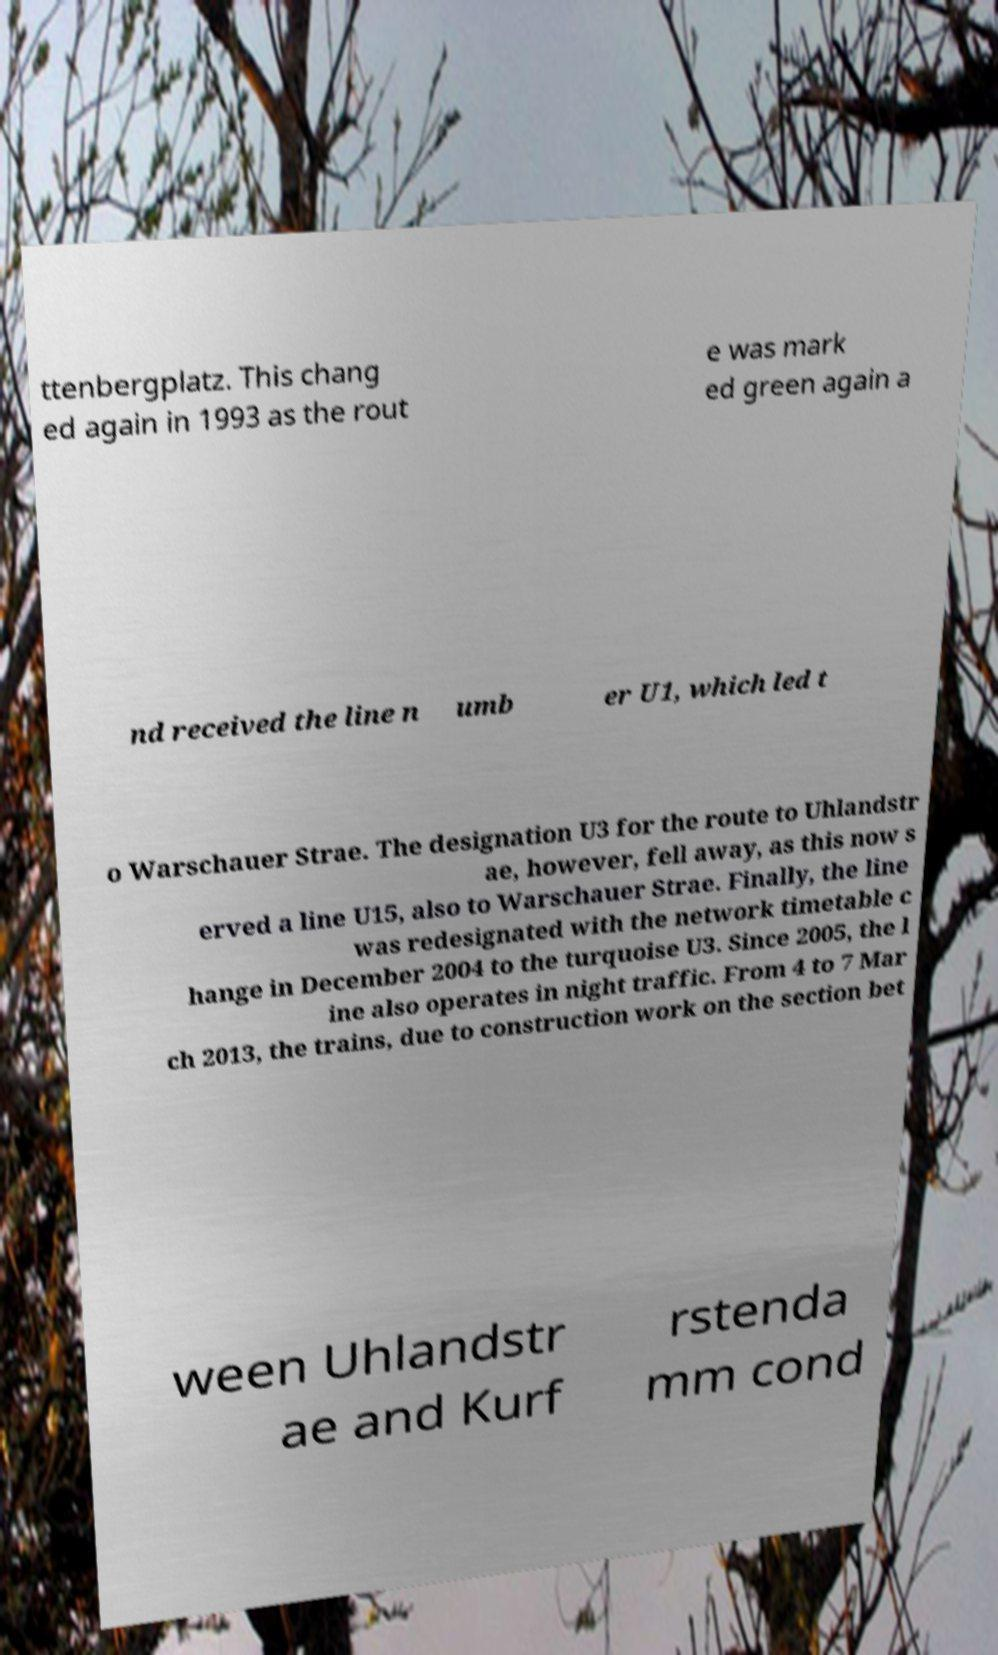I need the written content from this picture converted into text. Can you do that? ttenbergplatz. This chang ed again in 1993 as the rout e was mark ed green again a nd received the line n umb er U1, which led t o Warschauer Strae. The designation U3 for the route to Uhlandstr ae, however, fell away, as this now s erved a line U15, also to Warschauer Strae. Finally, the line was redesignated with the network timetable c hange in December 2004 to the turquoise U3. Since 2005, the l ine also operates in night traffic. From 4 to 7 Mar ch 2013, the trains, due to construction work on the section bet ween Uhlandstr ae and Kurf rstenda mm cond 